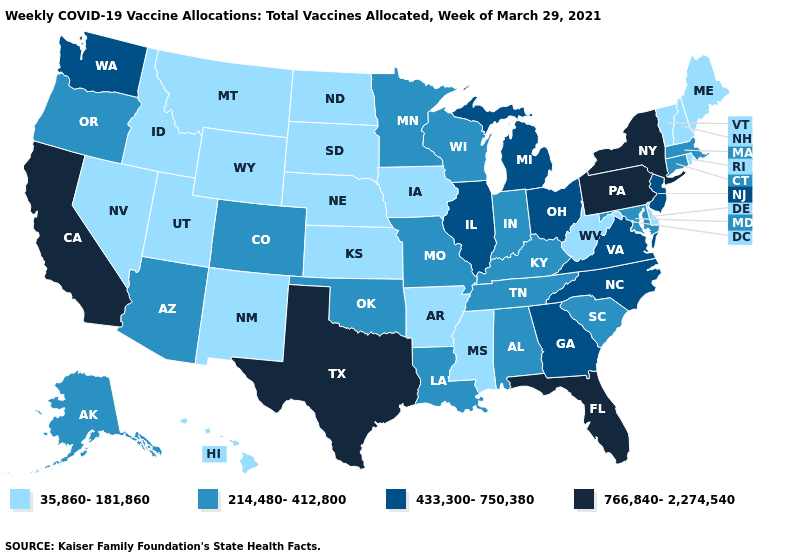What is the value of South Carolina?
Give a very brief answer. 214,480-412,800. What is the highest value in the USA?
Give a very brief answer. 766,840-2,274,540. Does Vermont have the lowest value in the Northeast?
Be succinct. Yes. Name the states that have a value in the range 433,300-750,380?
Answer briefly. Georgia, Illinois, Michigan, New Jersey, North Carolina, Ohio, Virginia, Washington. What is the lowest value in states that border Florida?
Keep it brief. 214,480-412,800. What is the lowest value in the South?
Keep it brief. 35,860-181,860. How many symbols are there in the legend?
Write a very short answer. 4. Does Indiana have the highest value in the MidWest?
Give a very brief answer. No. Does Oregon have the lowest value in the USA?
Concise answer only. No. Which states hav the highest value in the Northeast?
Give a very brief answer. New York, Pennsylvania. What is the value of Texas?
Keep it brief. 766,840-2,274,540. What is the value of Montana?
Write a very short answer. 35,860-181,860. Name the states that have a value in the range 214,480-412,800?
Answer briefly. Alabama, Alaska, Arizona, Colorado, Connecticut, Indiana, Kentucky, Louisiana, Maryland, Massachusetts, Minnesota, Missouri, Oklahoma, Oregon, South Carolina, Tennessee, Wisconsin. Name the states that have a value in the range 766,840-2,274,540?
Give a very brief answer. California, Florida, New York, Pennsylvania, Texas. Among the states that border New Mexico , does Texas have the highest value?
Concise answer only. Yes. 